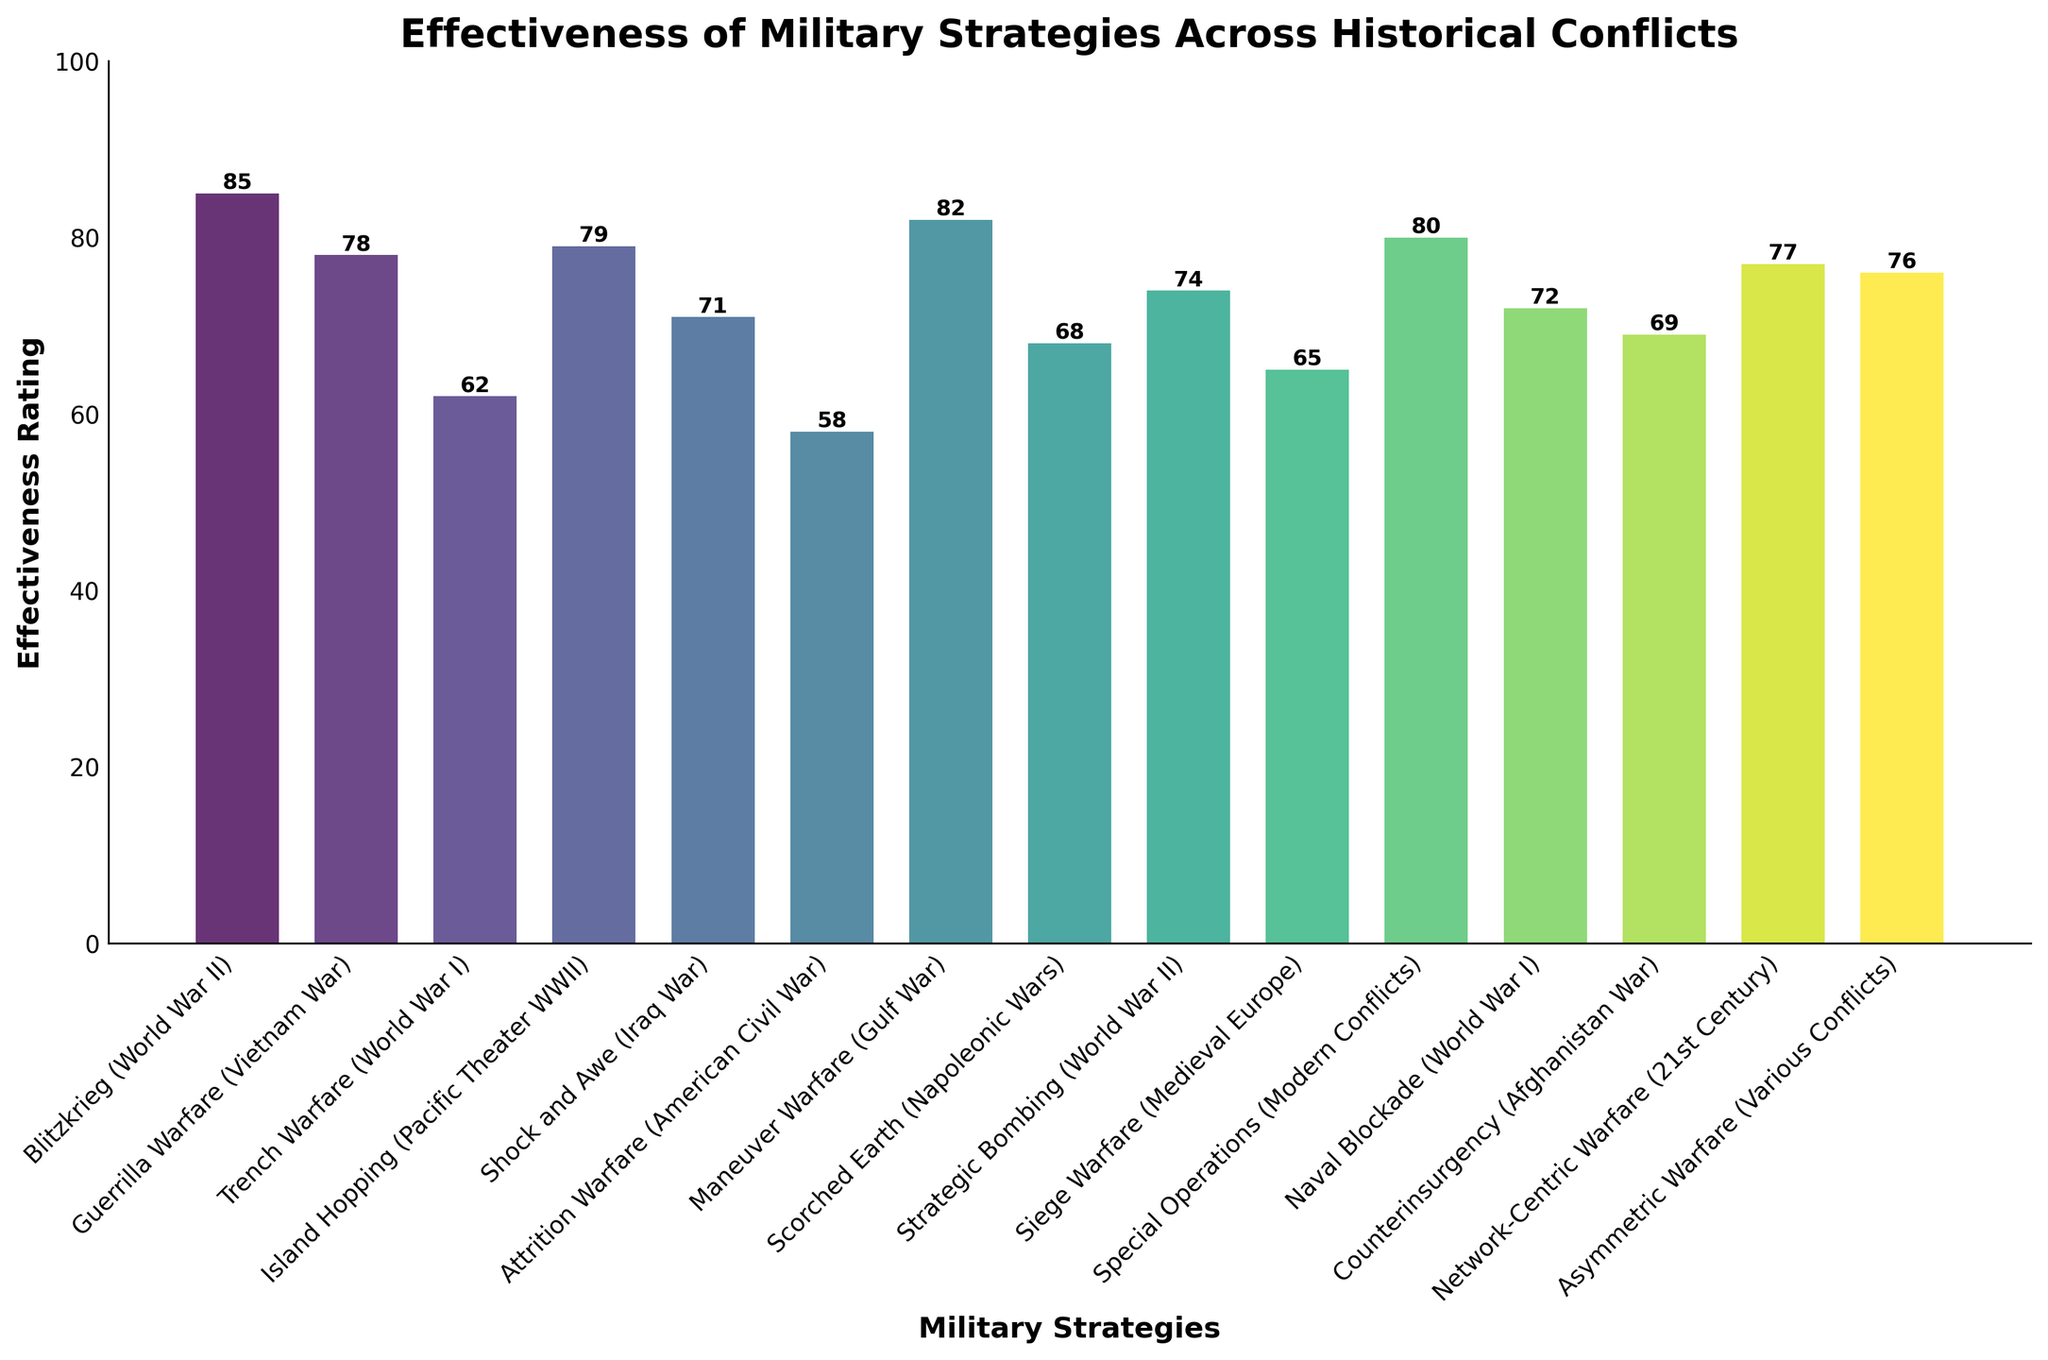What strategy has the highest effectiveness rating? Look at the top of the bars and identify the highest one. The highest bar belongs to Blitzkrieg (World War II) with a rating of 85.
Answer: Blitzkrieg (World War II) Which strategies have an effectiveness rating higher than 75? Identify the bars with ratings greater than 75. These are Blitzkrieg (World War II) - 85, Maneuver Warfare (Gulf War) - 82, Special Operations (Modern Conflicts) - 80, Island Hopping (Pacific Theater WWII) - 79, Guerrilla Warfare (Vietnam War) - 78, Network-Centric Warfare (21st Century) - 77, and Asymmetric Warfare (Various Conflicts) - 76.
Answer: Blitzkrieg (World War II), Maneuver Warfare (Gulf War), Special Operations (Modern Conflicts), Island Hopping (Pacific Theater WWII), Guerrilla Warfare (Vietnam War), Network-Centric Warfare (21st Century), Asymmetric Warfare (Various Conflicts) What is the average effectiveness rating of all strategies? Add up all the effectiveness ratings and divide by the number of strategies, which is 15. The total sum of ratings is 64+78+62+79+71+58+82+68+74+65+80+72+69+77+76 = 1052. The average rating is 1052 / 15.
Answer: 70.13 Which strategy has the lowest effectiveness rating? Look at the bottom of the bars and identify the shortest one. The shortest bar belongs to Attrition Warfare (American Civil War) with a rating of 58.
Answer: Attrition Warfare (American Civil War) How much higher is the effectiveness rating of Blitzkrieg (World War II) compared to Trench Warfare (World War I)? Subtract the effectiveness rating of Trench Warfare (World War I) from Blitzkrieg (World War II), which is 85 - 62.
Answer: 23 What is the color and height of the bar representing Guerrilla Warfare (Vietnam War)? The bar representing Guerrilla Warfare (Vietnam War) is greenish (since viridis color map was used, it leans towards green for higher values) and has a height corresponding to an effectiveness rating of 78.
Answer: Greenish, 78 Which strategy corresponds to the bar that is positioned exactly in the middle when sorted by effectiveness? Arrange the strategies by their effectiveness ratings and identify the one in the middle. Sorting by effectiveness ratings: 58, 62, 65, 68, 69, 71, 72, 74, 76, 77, 78, 79, 80, 82, 85. The middle value is 74, which corresponds to Strategic Bombing (World War II).
Answer: Strategic Bombing (World War II) Which two strategies have effectiveness ratings closest to each other? Compare the effectiveness rating differences between adjacent strategies when sorted by effectiveness. The smallest difference is between Guerrilla Warfare (Vietnam War) and Network-Centric Warfare (21st Century) (78-77 = 1).
Answer: Guerrilla Warfare (Vietnam War) and Network-Centric Warfare (21st Century) 